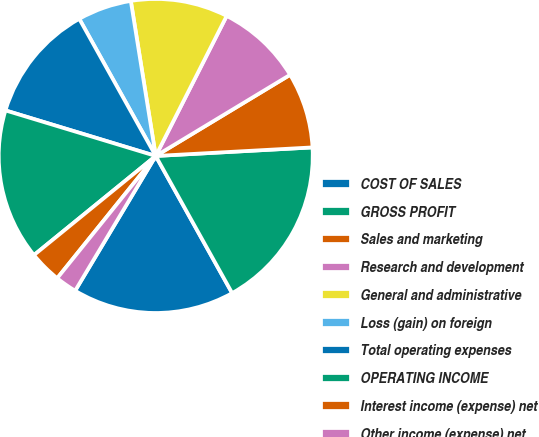<chart> <loc_0><loc_0><loc_500><loc_500><pie_chart><fcel>COST OF SALES<fcel>GROSS PROFIT<fcel>Sales and marketing<fcel>Research and development<fcel>General and administrative<fcel>Loss (gain) on foreign<fcel>Total operating expenses<fcel>OPERATING INCOME<fcel>Interest income (expense) net<fcel>Other income (expense) net<nl><fcel>16.67%<fcel>17.78%<fcel>7.78%<fcel>8.89%<fcel>10.0%<fcel>5.56%<fcel>12.22%<fcel>15.56%<fcel>3.33%<fcel>2.22%<nl></chart> 